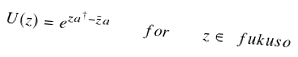<formula> <loc_0><loc_0><loc_500><loc_500>U ( z ) = e ^ { z a ^ { \dagger } - \bar { z } a } \quad f o r \quad z \in \ f u k u s o</formula> 